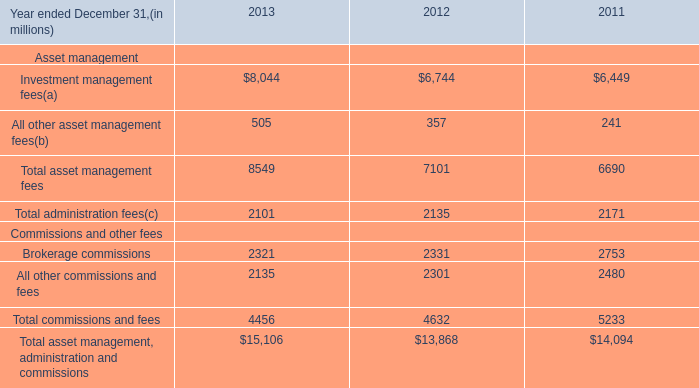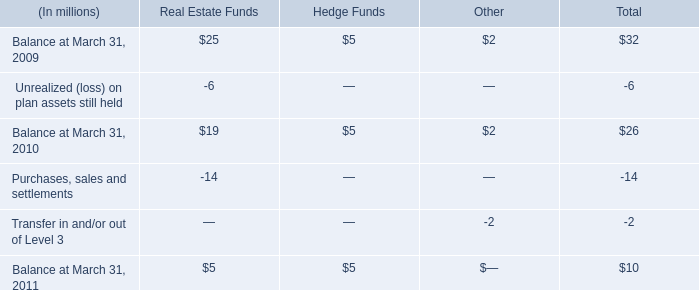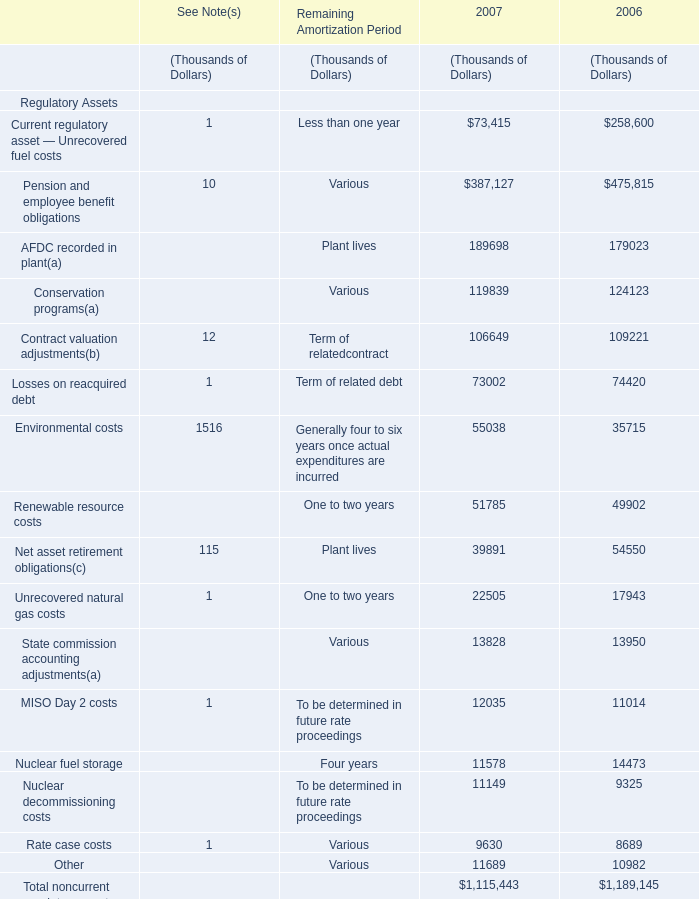What was the average value of AFDC recorded in plant,Conservation programs,Contract valuation adjustments( in 2007? (in thousand) 
Computations: ((189698 + 119839) + 106649)
Answer: 416186.0. 